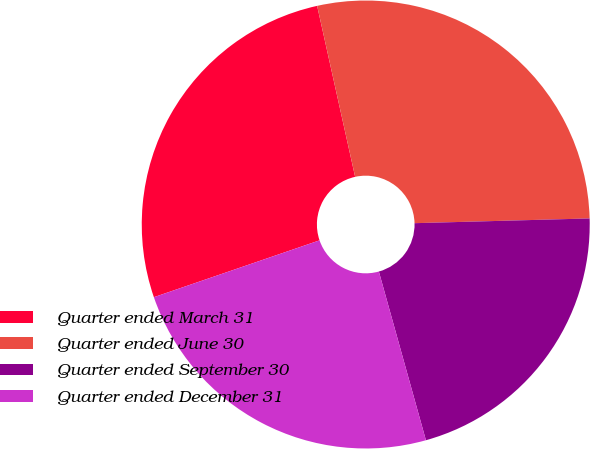<chart> <loc_0><loc_0><loc_500><loc_500><pie_chart><fcel>Quarter ended March 31<fcel>Quarter ended June 30<fcel>Quarter ended September 30<fcel>Quarter ended December 31<nl><fcel>26.78%<fcel>28.05%<fcel>21.1%<fcel>24.07%<nl></chart> 